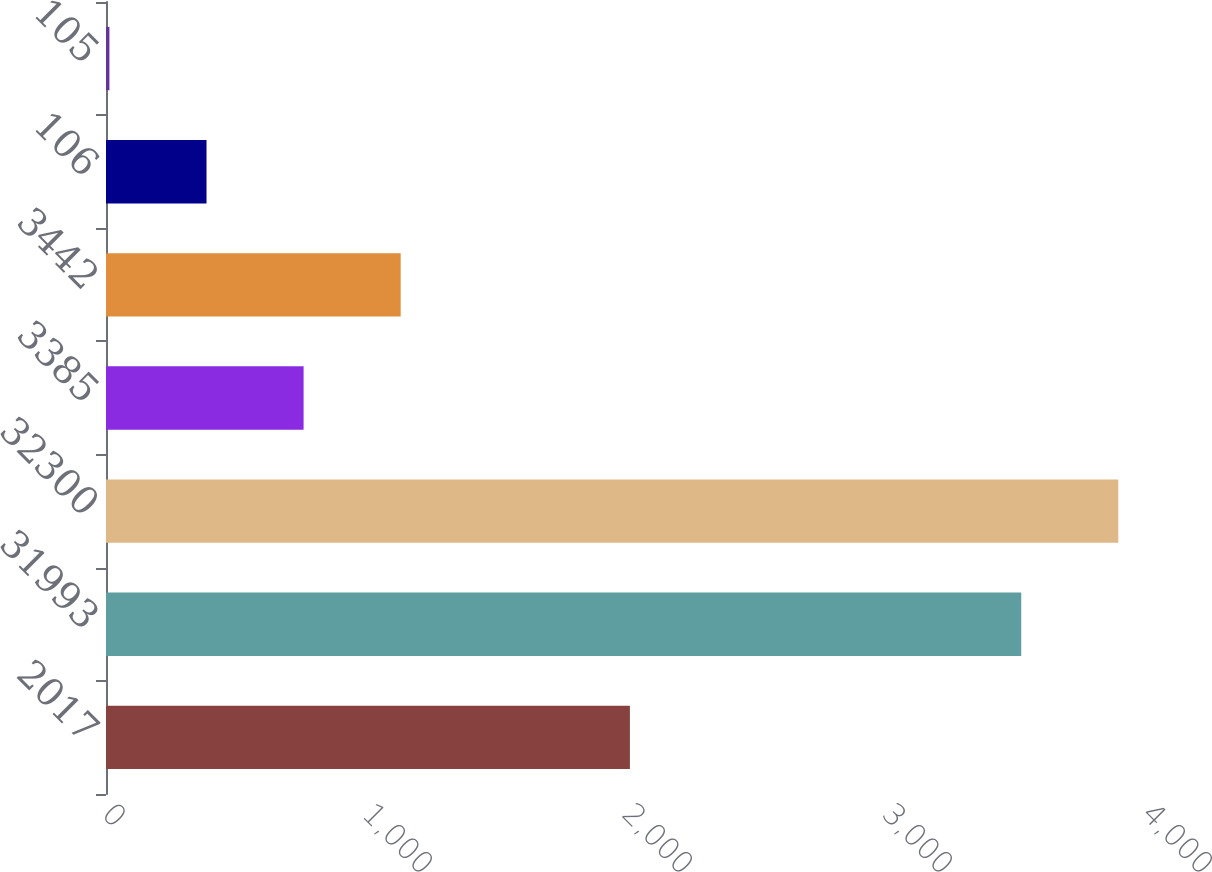Convert chart. <chart><loc_0><loc_0><loc_500><loc_500><bar_chart><fcel>2017<fcel>31993<fcel>32300<fcel>3385<fcel>3442<fcel>106<fcel>105<nl><fcel>2015<fcel>3520.1<fcel>3893.5<fcel>760<fcel>1133.4<fcel>386.6<fcel>13.2<nl></chart> 